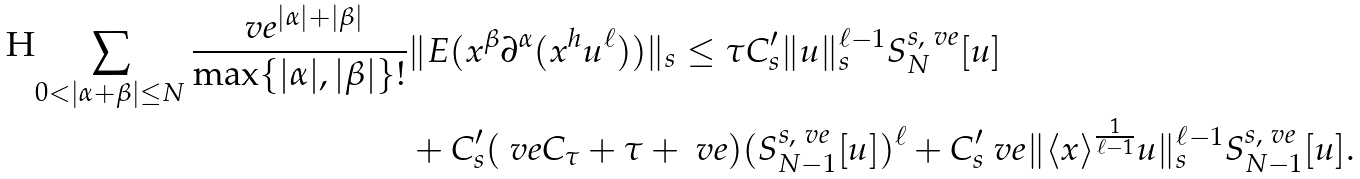<formula> <loc_0><loc_0><loc_500><loc_500>\sum _ { 0 < | \alpha + \beta | \leq N } \frac { \ v e ^ { | \alpha | + | \beta | } } { \max \{ | \alpha | , | \beta | \} ! } & \| E ( x ^ { \beta } \partial ^ { \alpha } ( x ^ { h } u ^ { \ell } ) ) \| _ { s } \leq \tau C ^ { \prime } _ { s } \| u \| _ { s } ^ { \ell - 1 } S _ { N } ^ { s , \ v e } [ u ] \\ & + C ^ { \prime } _ { s } ( \ v e C _ { \tau } + \tau + \ v e ) ( S _ { N - 1 } ^ { s , \ v e } [ u ] ) ^ { \ell } + C ^ { \prime } _ { s } \ v e \| \langle x \rangle ^ { \frac { 1 } { \ell - 1 } } u \| ^ { \ell - 1 } _ { s } S _ { N - 1 } ^ { s , \ v e } [ u ] .</formula> 